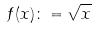<formula> <loc_0><loc_0><loc_500><loc_500>f ( x ) \colon = \sqrt { x }</formula> 